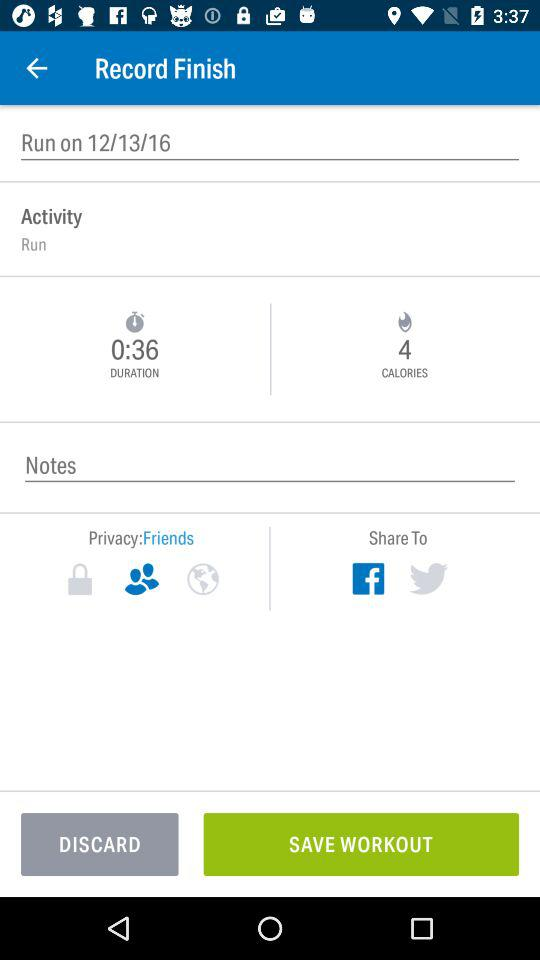What is the privacy setting set to? The privacy setting is set to "Friends". 